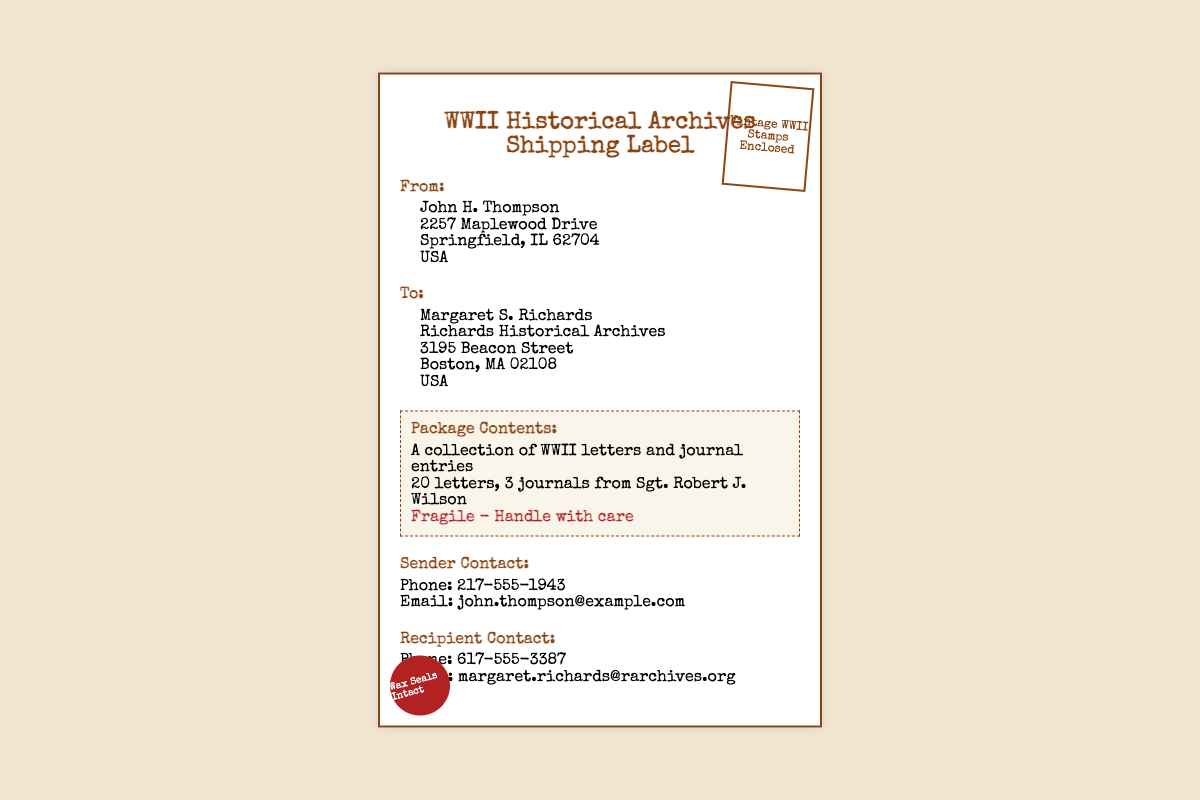What is the sender's name? The sender's name is mentioned in the 'From' section of the document as John H. Thompson.
Answer: John H. Thompson What is the recipient's email? The recipient's email is stated in the 'Recipient Contact' section of the document.
Answer: margaret.richards@rarchives.org How many letters are included in the package? The number of letters is mentioned in the 'Package Contents' section.
Answer: 20 letters What is the special handling instruction? The special handling instruction is highlighted in the 'Package Details' section of the document.
Answer: Fragile - Handle with care What is the address of the sender? The sender's full address can be found in the 'From' section of the document.
Answer: 2257 Maplewood Drive, Springfield, IL 62704, USA Who is the recipient? The recipient's name is provided in the 'To' section of the document.
Answer: Margaret S. Richards What are the package contents? The package contents are listed in the 'Package Details' section.
Answer: A collection of WWII letters and journal entries What is the sender's phone number? The sender's phone number is listed in the 'Sender Contact' section of the document.
Answer: 217-555-1943 What type of document is this? The title of the document at the top specifies the nature of the document.
Answer: Shipping Label 